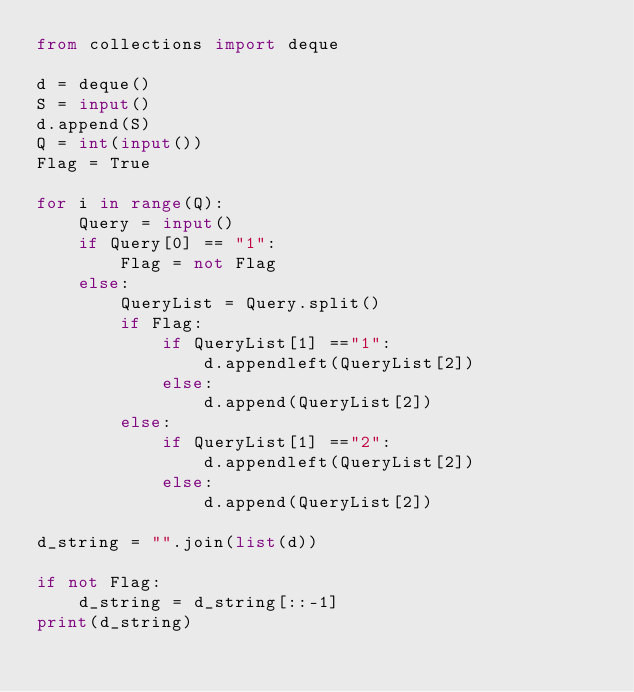<code> <loc_0><loc_0><loc_500><loc_500><_Python_>from collections import deque

d = deque()
S = input()
d.append(S)
Q = int(input())
Flag = True
 
for i in range(Q):
    Query = input()
    if Query[0] == "1":
        Flag = not Flag
    else:
        QueryList = Query.split()
        if Flag:
            if QueryList[1] =="1":
                d.appendleft(QueryList[2])
            else:
                d.append(QueryList[2])
        else:
            if QueryList[1] =="2":
                d.appendleft(QueryList[2])
            else:
                d.append(QueryList[2])

d_string = "".join(list(d))

if not Flag:
    d_string = d_string[::-1]    
print(d_string)</code> 